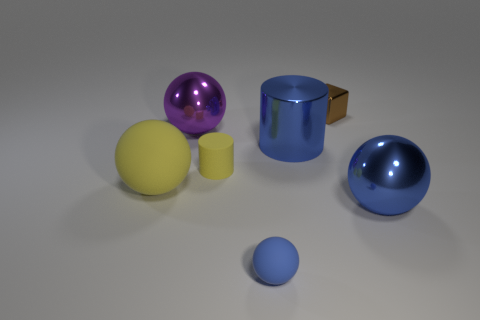Subtract 1 balls. How many balls are left? 3 Add 2 big yellow objects. How many objects exist? 9 Subtract all balls. How many objects are left? 3 Add 7 yellow cylinders. How many yellow cylinders are left? 8 Add 5 green things. How many green things exist? 5 Subtract 0 green blocks. How many objects are left? 7 Subtract all large metallic spheres. Subtract all big purple metallic spheres. How many objects are left? 4 